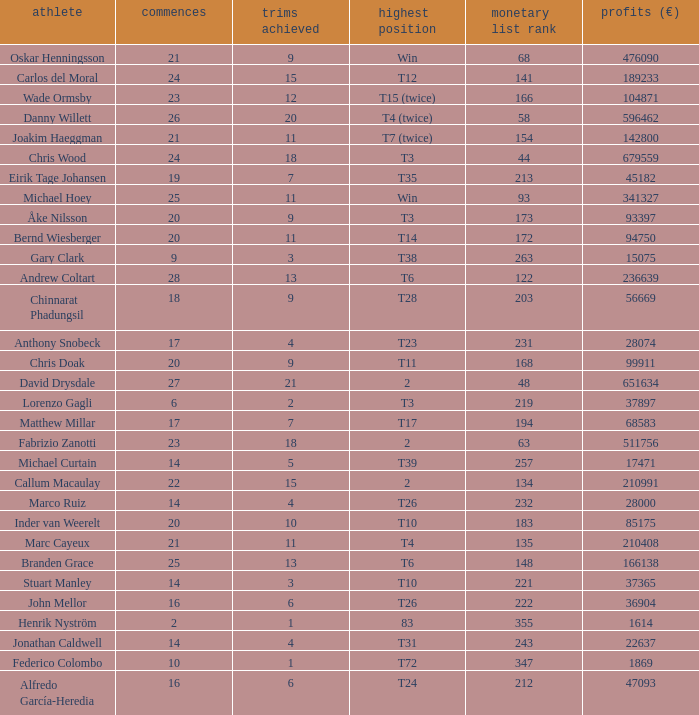How many cuts did Gary Clark make? 3.0. 